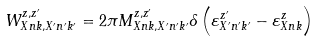Convert formula to latex. <formula><loc_0><loc_0><loc_500><loc_500>W _ { X n k , X ^ { \prime } n ^ { \prime } k ^ { \prime } } ^ { z , z ^ { \prime } } = 2 \pi M _ { X n k , X ^ { \prime } n ^ { \prime } k ^ { \prime } } ^ { z , z ^ { \prime } } \delta \left ( \varepsilon _ { X ^ { \prime } n ^ { \prime } k ^ { \prime } } ^ { z ^ { \prime } } - \varepsilon _ { X n k } ^ { z } \right )</formula> 